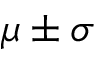Convert formula to latex. <formula><loc_0><loc_0><loc_500><loc_500>\mu \pm \sigma</formula> 